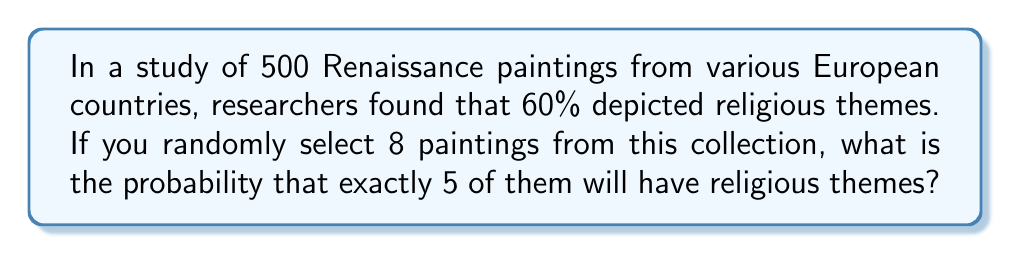Teach me how to tackle this problem. To solve this problem, we'll use the binomial probability distribution, which is appropriate for situations with a fixed number of independent trials, each with the same probability of success.

Let's define our parameters:
- $n = 8$ (number of paintings selected)
- $p = 0.60$ (probability of a painting having a religious theme)
- $k = 5$ (number of successes we're interested in)

The binomial probability formula is:

$$P(X = k) = \binom{n}{k} p^k (1-p)^{n-k}$$

Where $\binom{n}{k}$ is the binomial coefficient, calculated as:

$$\binom{n}{k} = \frac{n!}{k!(n-k)!}$$

Step 1: Calculate the binomial coefficient
$$\binom{8}{5} = \frac{8!}{5!(8-5)!} = \frac{8!}{5!3!} = 56$$

Step 2: Calculate $p^k$ and $(1-p)^{n-k}$
$p^k = 0.60^5 = 0.07776$
$(1-p)^{n-k} = 0.40^3 = 0.064$

Step 3: Multiply all parts together
$P(X = 5) = 56 \times 0.07776 \times 0.064 = 0.27885$

Therefore, the probability of selecting exactly 5 paintings with religious themes out of 8 randomly selected Renaissance paintings is approximately 0.27885 or 27.885%.
Answer: 0.27885 